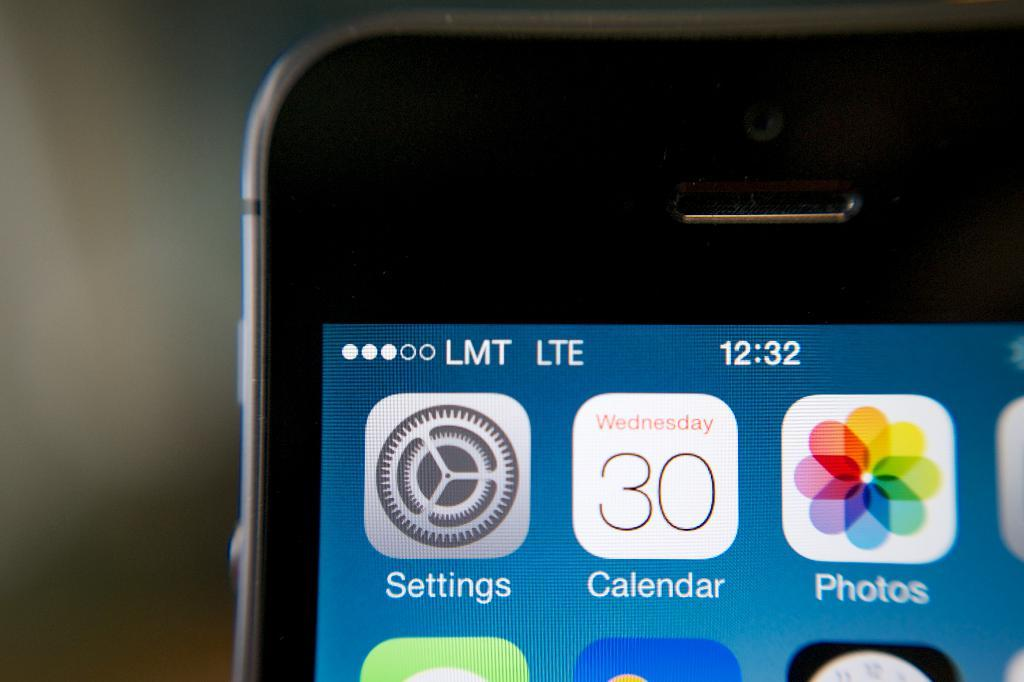<image>
Provide a brief description of the given image. A phone with the calendar app with the calendar app showing the day Wednesday. 